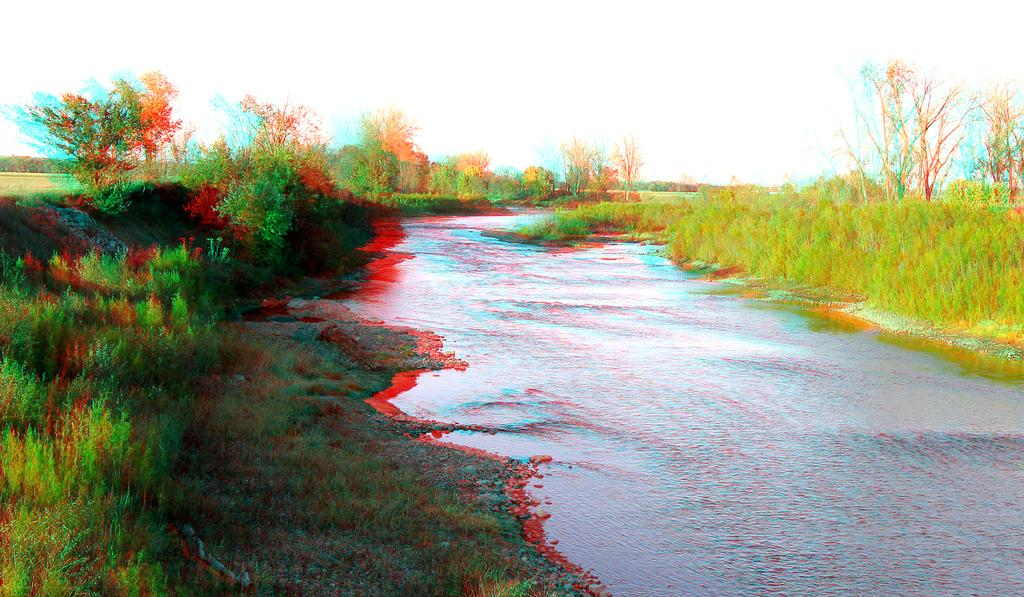What is the main subject in the middle of the image? There is water in the middle of the image. What can be seen on either side of the water? There are many plants on either side of the water. What type of joke is being told by the camera in the image? There is no camera present in the image, and therefore no joke can be attributed to it. 